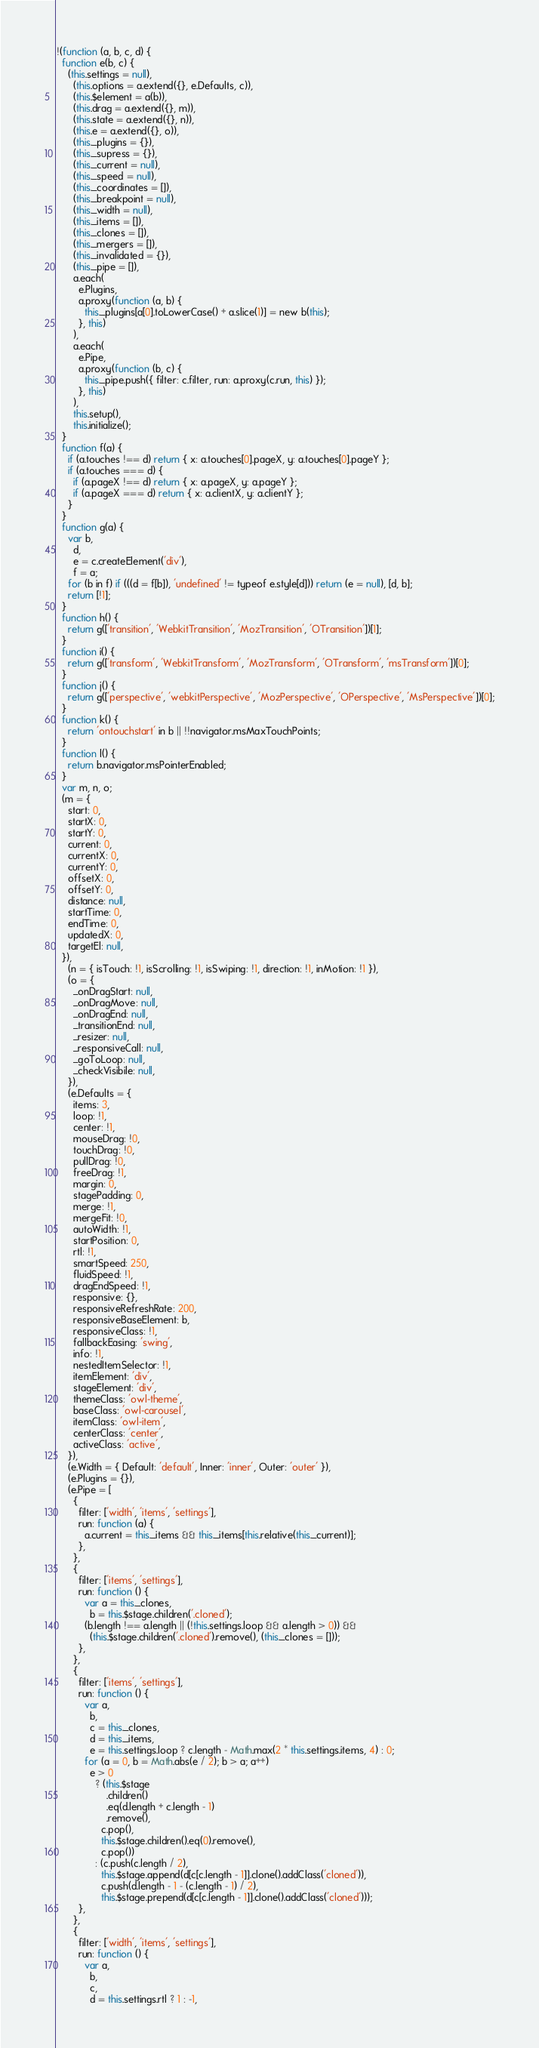<code> <loc_0><loc_0><loc_500><loc_500><_JavaScript_>!(function (a, b, c, d) {
  function e(b, c) {
    (this.settings = null),
      (this.options = a.extend({}, e.Defaults, c)),
      (this.$element = a(b)),
      (this.drag = a.extend({}, m)),
      (this.state = a.extend({}, n)),
      (this.e = a.extend({}, o)),
      (this._plugins = {}),
      (this._supress = {}),
      (this._current = null),
      (this._speed = null),
      (this._coordinates = []),
      (this._breakpoint = null),
      (this._width = null),
      (this._items = []),
      (this._clones = []),
      (this._mergers = []),
      (this._invalidated = {}),
      (this._pipe = []),
      a.each(
        e.Plugins,
        a.proxy(function (a, b) {
          this._plugins[a[0].toLowerCase() + a.slice(1)] = new b(this);
        }, this)
      ),
      a.each(
        e.Pipe,
        a.proxy(function (b, c) {
          this._pipe.push({ filter: c.filter, run: a.proxy(c.run, this) });
        }, this)
      ),
      this.setup(),
      this.initialize();
  }
  function f(a) {
    if (a.touches !== d) return { x: a.touches[0].pageX, y: a.touches[0].pageY };
    if (a.touches === d) {
      if (a.pageX !== d) return { x: a.pageX, y: a.pageY };
      if (a.pageX === d) return { x: a.clientX, y: a.clientY };
    }
  }
  function g(a) {
    var b,
      d,
      e = c.createElement('div'),
      f = a;
    for (b in f) if (((d = f[b]), 'undefined' != typeof e.style[d])) return (e = null), [d, b];
    return [!1];
  }
  function h() {
    return g(['transition', 'WebkitTransition', 'MozTransition', 'OTransition'])[1];
  }
  function i() {
    return g(['transform', 'WebkitTransform', 'MozTransform', 'OTransform', 'msTransform'])[0];
  }
  function j() {
    return g(['perspective', 'webkitPerspective', 'MozPerspective', 'OPerspective', 'MsPerspective'])[0];
  }
  function k() {
    return 'ontouchstart' in b || !!navigator.msMaxTouchPoints;
  }
  function l() {
    return b.navigator.msPointerEnabled;
  }
  var m, n, o;
  (m = {
    start: 0,
    startX: 0,
    startY: 0,
    current: 0,
    currentX: 0,
    currentY: 0,
    offsetX: 0,
    offsetY: 0,
    distance: null,
    startTime: 0,
    endTime: 0,
    updatedX: 0,
    targetEl: null,
  }),
    (n = { isTouch: !1, isScrolling: !1, isSwiping: !1, direction: !1, inMotion: !1 }),
    (o = {
      _onDragStart: null,
      _onDragMove: null,
      _onDragEnd: null,
      _transitionEnd: null,
      _resizer: null,
      _responsiveCall: null,
      _goToLoop: null,
      _checkVisibile: null,
    }),
    (e.Defaults = {
      items: 3,
      loop: !1,
      center: !1,
      mouseDrag: !0,
      touchDrag: !0,
      pullDrag: !0,
      freeDrag: !1,
      margin: 0,
      stagePadding: 0,
      merge: !1,
      mergeFit: !0,
      autoWidth: !1,
      startPosition: 0,
      rtl: !1,
      smartSpeed: 250,
      fluidSpeed: !1,
      dragEndSpeed: !1,
      responsive: {},
      responsiveRefreshRate: 200,
      responsiveBaseElement: b,
      responsiveClass: !1,
      fallbackEasing: 'swing',
      info: !1,
      nestedItemSelector: !1,
      itemElement: 'div',
      stageElement: 'div',
      themeClass: 'owl-theme',
      baseClass: 'owl-carousel',
      itemClass: 'owl-item',
      centerClass: 'center',
      activeClass: 'active',
    }),
    (e.Width = { Default: 'default', Inner: 'inner', Outer: 'outer' }),
    (e.Plugins = {}),
    (e.Pipe = [
      {
        filter: ['width', 'items', 'settings'],
        run: function (a) {
          a.current = this._items && this._items[this.relative(this._current)];
        },
      },
      {
        filter: ['items', 'settings'],
        run: function () {
          var a = this._clones,
            b = this.$stage.children('.cloned');
          (b.length !== a.length || (!this.settings.loop && a.length > 0)) &&
            (this.$stage.children('.cloned').remove(), (this._clones = []));
        },
      },
      {
        filter: ['items', 'settings'],
        run: function () {
          var a,
            b,
            c = this._clones,
            d = this._items,
            e = this.settings.loop ? c.length - Math.max(2 * this.settings.items, 4) : 0;
          for (a = 0, b = Math.abs(e / 2); b > a; a++)
            e > 0
              ? (this.$stage
                  .children()
                  .eq(d.length + c.length - 1)
                  .remove(),
                c.pop(),
                this.$stage.children().eq(0).remove(),
                c.pop())
              : (c.push(c.length / 2),
                this.$stage.append(d[c[c.length - 1]].clone().addClass('cloned')),
                c.push(d.length - 1 - (c.length - 1) / 2),
                this.$stage.prepend(d[c[c.length - 1]].clone().addClass('cloned')));
        },
      },
      {
        filter: ['width', 'items', 'settings'],
        run: function () {
          var a,
            b,
            c,
            d = this.settings.rtl ? 1 : -1,</code> 